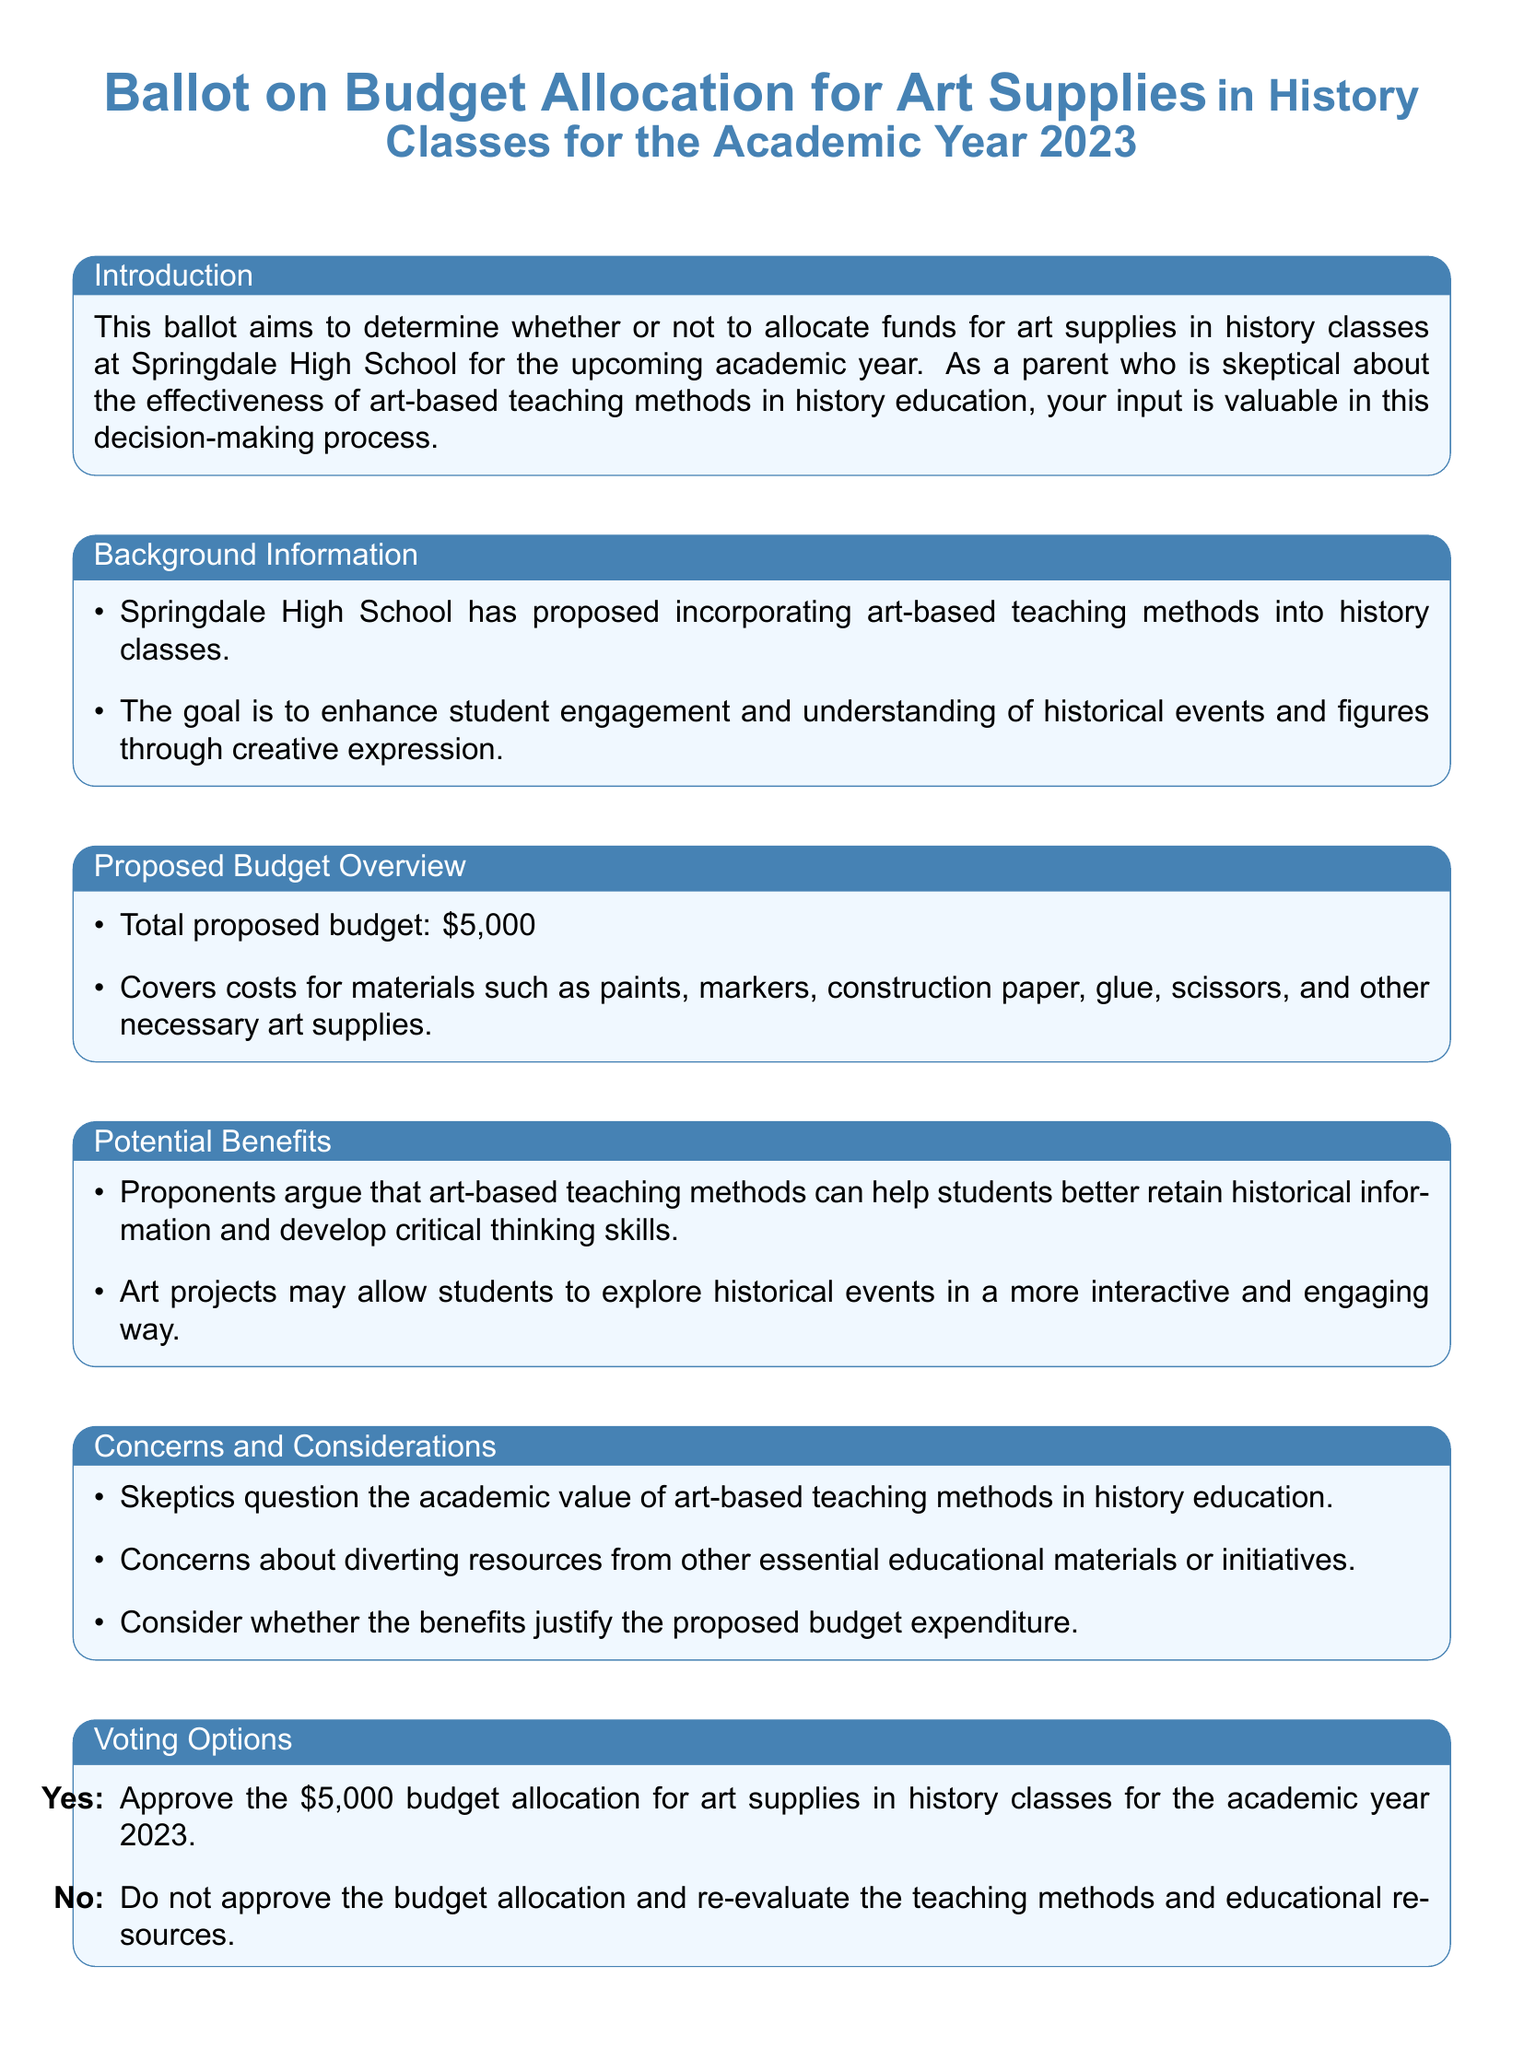What is the total proposed budget for art supplies? The total proposed budget for art supplies in history classes is clearly listed in the document.
Answer: $5,000 What materials are included in the proposed budget? The document provides a list of materials that the budget will cover.
Answer: paints, markers, construction paper, glue, scissors, and other necessary art supplies What is the main goal of incorporating art-based teaching methods? The document mentions the goal of these methods in enhancing student engagement and understanding.
Answer: Enhancing student engagement and understanding What are the two voting options presented in the ballot? The document explicitly states the options available for voting regarding the budget allocation.
Answer: Yes and No What is a concern raised by skeptics about art-based teaching methods? The document outlines specific concerns regarding the academic value of art-based teaching methods in history education.
Answer: Academic value How much funding is proposed for art supplies in history classes? This information is specified in the proposal overview section of the document.
Answer: $5,000 What does the feedback section request from parents? The document indicates the type of input that parents can provide in this section.
Answer: Additional comments or concerns 